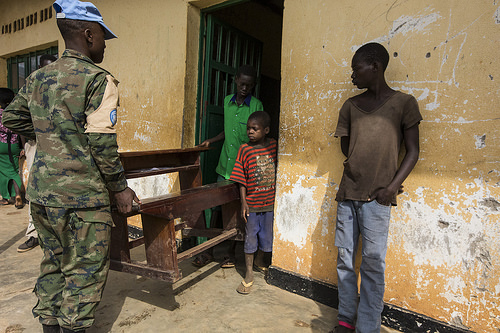<image>
Can you confirm if the boy is under the wall? No. The boy is not positioned under the wall. The vertical relationship between these objects is different. 